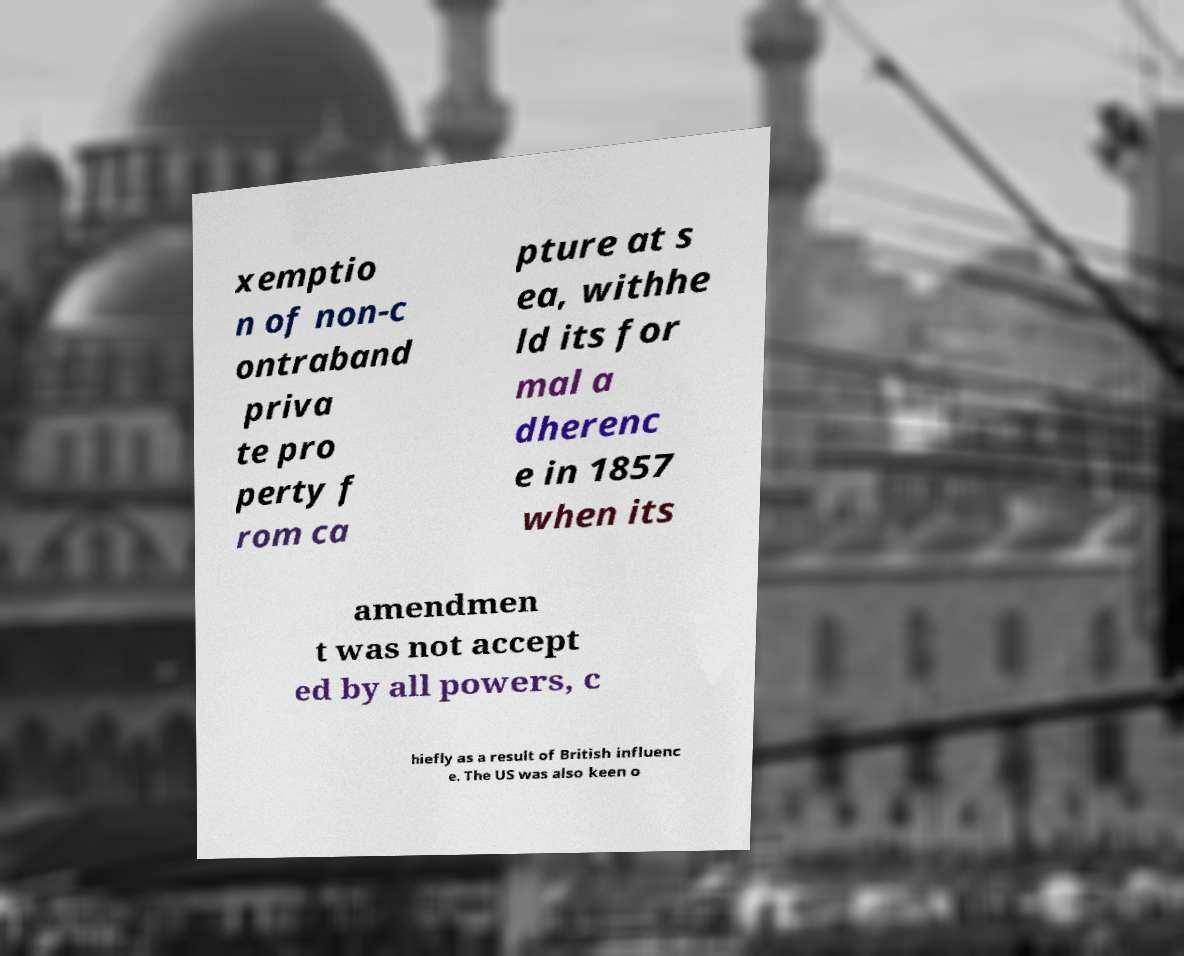Can you accurately transcribe the text from the provided image for me? xemptio n of non-c ontraband priva te pro perty f rom ca pture at s ea, withhe ld its for mal a dherenc e in 1857 when its amendmen t was not accept ed by all powers, c hiefly as a result of British influenc e. The US was also keen o 